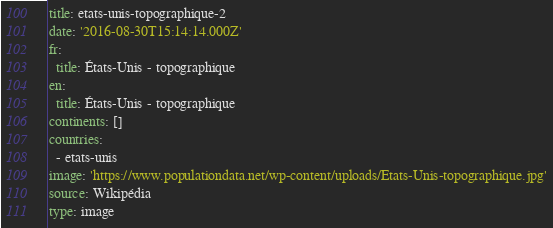<code> <loc_0><loc_0><loc_500><loc_500><_YAML_>title: etats-unis-topographique-2
date: '2016-08-30T15:14:14.000Z'
fr:
  title: États-Unis - topographique
en:
  title: États-Unis - topographique
continents: []
countries:
  - etats-unis
image: 'https://www.populationdata.net/wp-content/uploads/Etats-Unis-topographique.jpg'
source: Wikipédia
type: image
</code> 